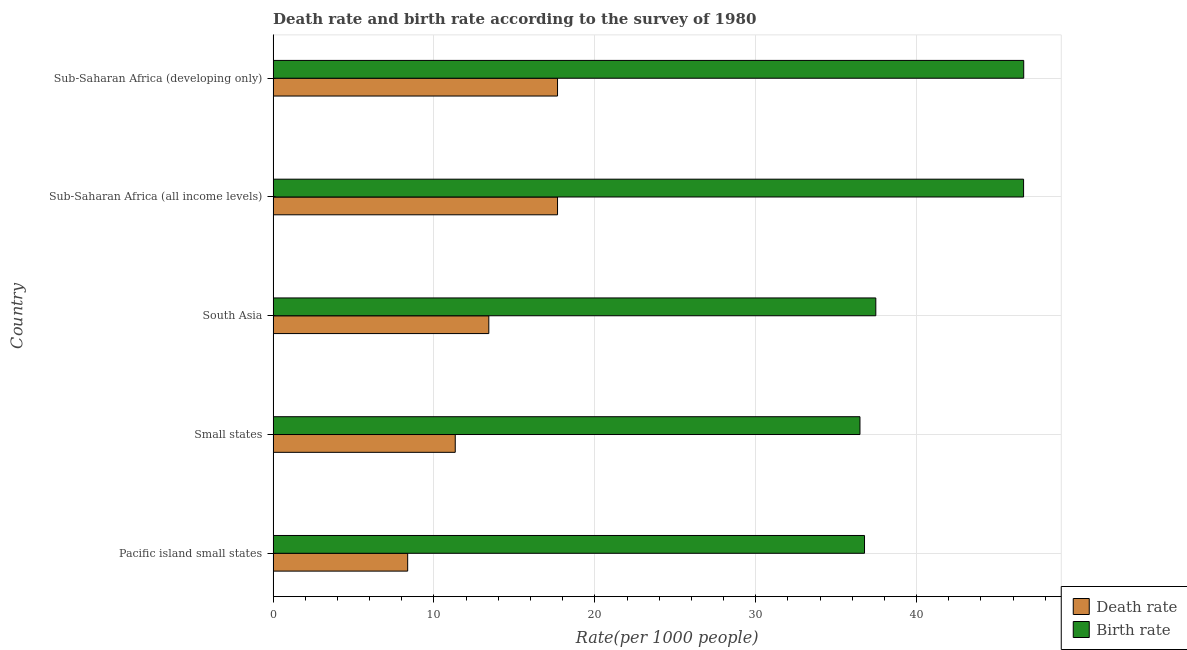How many different coloured bars are there?
Offer a very short reply. 2. Are the number of bars per tick equal to the number of legend labels?
Provide a succinct answer. Yes. Are the number of bars on each tick of the Y-axis equal?
Offer a very short reply. Yes. How many bars are there on the 4th tick from the top?
Keep it short and to the point. 2. How many bars are there on the 4th tick from the bottom?
Give a very brief answer. 2. What is the label of the 2nd group of bars from the top?
Ensure brevity in your answer.  Sub-Saharan Africa (all income levels). In how many cases, is the number of bars for a given country not equal to the number of legend labels?
Provide a succinct answer. 0. What is the birth rate in South Asia?
Give a very brief answer. 37.47. Across all countries, what is the maximum death rate?
Offer a very short reply. 17.68. Across all countries, what is the minimum birth rate?
Make the answer very short. 36.48. In which country was the birth rate maximum?
Offer a terse response. Sub-Saharan Africa (developing only). In which country was the birth rate minimum?
Your response must be concise. Small states. What is the total birth rate in the graph?
Provide a short and direct response. 204.03. What is the difference between the birth rate in Pacific island small states and that in Sub-Saharan Africa (developing only)?
Keep it short and to the point. -9.9. What is the difference between the death rate in South Asia and the birth rate in Sub-Saharan Africa (developing only)?
Give a very brief answer. -33.25. What is the average death rate per country?
Provide a short and direct response. 13.69. What is the difference between the death rate and birth rate in Pacific island small states?
Your answer should be very brief. -28.4. What is the ratio of the birth rate in Pacific island small states to that in Sub-Saharan Africa (all income levels)?
Provide a succinct answer. 0.79. Is the difference between the death rate in Pacific island small states and Sub-Saharan Africa (developing only) greater than the difference between the birth rate in Pacific island small states and Sub-Saharan Africa (developing only)?
Make the answer very short. Yes. What is the difference between the highest and the second highest birth rate?
Ensure brevity in your answer.  0.01. What is the difference between the highest and the lowest birth rate?
Your response must be concise. 10.18. What does the 1st bar from the top in Sub-Saharan Africa (developing only) represents?
Provide a short and direct response. Birth rate. What does the 1st bar from the bottom in Sub-Saharan Africa (developing only) represents?
Offer a very short reply. Death rate. Are all the bars in the graph horizontal?
Your answer should be compact. Yes. How many countries are there in the graph?
Your answer should be compact. 5. What is the difference between two consecutive major ticks on the X-axis?
Your answer should be very brief. 10. Are the values on the major ticks of X-axis written in scientific E-notation?
Your answer should be very brief. No. Does the graph contain any zero values?
Give a very brief answer. No. What is the title of the graph?
Your answer should be very brief. Death rate and birth rate according to the survey of 1980. Does "Taxes on profits and capital gains" appear as one of the legend labels in the graph?
Provide a succinct answer. No. What is the label or title of the X-axis?
Keep it short and to the point. Rate(per 1000 people). What is the label or title of the Y-axis?
Give a very brief answer. Country. What is the Rate(per 1000 people) in Death rate in Pacific island small states?
Keep it short and to the point. 8.36. What is the Rate(per 1000 people) in Birth rate in Pacific island small states?
Make the answer very short. 36.76. What is the Rate(per 1000 people) of Death rate in Small states?
Ensure brevity in your answer.  11.32. What is the Rate(per 1000 people) in Birth rate in Small states?
Your answer should be compact. 36.48. What is the Rate(per 1000 people) of Death rate in South Asia?
Your response must be concise. 13.41. What is the Rate(per 1000 people) in Birth rate in South Asia?
Ensure brevity in your answer.  37.47. What is the Rate(per 1000 people) of Death rate in Sub-Saharan Africa (all income levels)?
Ensure brevity in your answer.  17.68. What is the Rate(per 1000 people) in Birth rate in Sub-Saharan Africa (all income levels)?
Your response must be concise. 46.65. What is the Rate(per 1000 people) in Death rate in Sub-Saharan Africa (developing only)?
Your answer should be very brief. 17.68. What is the Rate(per 1000 people) in Birth rate in Sub-Saharan Africa (developing only)?
Offer a very short reply. 46.66. Across all countries, what is the maximum Rate(per 1000 people) in Death rate?
Make the answer very short. 17.68. Across all countries, what is the maximum Rate(per 1000 people) of Birth rate?
Offer a terse response. 46.66. Across all countries, what is the minimum Rate(per 1000 people) in Death rate?
Offer a terse response. 8.36. Across all countries, what is the minimum Rate(per 1000 people) in Birth rate?
Give a very brief answer. 36.48. What is the total Rate(per 1000 people) of Death rate in the graph?
Provide a succinct answer. 68.46. What is the total Rate(per 1000 people) of Birth rate in the graph?
Offer a terse response. 204.03. What is the difference between the Rate(per 1000 people) in Death rate in Pacific island small states and that in Small states?
Your answer should be very brief. -2.96. What is the difference between the Rate(per 1000 people) of Birth rate in Pacific island small states and that in Small states?
Provide a succinct answer. 0.28. What is the difference between the Rate(per 1000 people) in Death rate in Pacific island small states and that in South Asia?
Give a very brief answer. -5.04. What is the difference between the Rate(per 1000 people) in Birth rate in Pacific island small states and that in South Asia?
Provide a succinct answer. -0.7. What is the difference between the Rate(per 1000 people) of Death rate in Pacific island small states and that in Sub-Saharan Africa (all income levels)?
Your response must be concise. -9.32. What is the difference between the Rate(per 1000 people) of Birth rate in Pacific island small states and that in Sub-Saharan Africa (all income levels)?
Provide a succinct answer. -9.89. What is the difference between the Rate(per 1000 people) in Death rate in Pacific island small states and that in Sub-Saharan Africa (developing only)?
Your answer should be compact. -9.32. What is the difference between the Rate(per 1000 people) in Birth rate in Pacific island small states and that in Sub-Saharan Africa (developing only)?
Ensure brevity in your answer.  -9.9. What is the difference between the Rate(per 1000 people) of Death rate in Small states and that in South Asia?
Ensure brevity in your answer.  -2.09. What is the difference between the Rate(per 1000 people) of Birth rate in Small states and that in South Asia?
Your answer should be very brief. -0.98. What is the difference between the Rate(per 1000 people) in Death rate in Small states and that in Sub-Saharan Africa (all income levels)?
Your response must be concise. -6.36. What is the difference between the Rate(per 1000 people) of Birth rate in Small states and that in Sub-Saharan Africa (all income levels)?
Offer a terse response. -10.17. What is the difference between the Rate(per 1000 people) in Death rate in Small states and that in Sub-Saharan Africa (developing only)?
Give a very brief answer. -6.36. What is the difference between the Rate(per 1000 people) of Birth rate in Small states and that in Sub-Saharan Africa (developing only)?
Offer a very short reply. -10.18. What is the difference between the Rate(per 1000 people) in Death rate in South Asia and that in Sub-Saharan Africa (all income levels)?
Your response must be concise. -4.27. What is the difference between the Rate(per 1000 people) in Birth rate in South Asia and that in Sub-Saharan Africa (all income levels)?
Your answer should be very brief. -9.19. What is the difference between the Rate(per 1000 people) in Death rate in South Asia and that in Sub-Saharan Africa (developing only)?
Ensure brevity in your answer.  -4.27. What is the difference between the Rate(per 1000 people) of Birth rate in South Asia and that in Sub-Saharan Africa (developing only)?
Your answer should be compact. -9.2. What is the difference between the Rate(per 1000 people) of Death rate in Sub-Saharan Africa (all income levels) and that in Sub-Saharan Africa (developing only)?
Provide a succinct answer. 0. What is the difference between the Rate(per 1000 people) in Birth rate in Sub-Saharan Africa (all income levels) and that in Sub-Saharan Africa (developing only)?
Offer a terse response. -0.01. What is the difference between the Rate(per 1000 people) in Death rate in Pacific island small states and the Rate(per 1000 people) in Birth rate in Small states?
Offer a very short reply. -28.12. What is the difference between the Rate(per 1000 people) of Death rate in Pacific island small states and the Rate(per 1000 people) of Birth rate in South Asia?
Your answer should be compact. -29.1. What is the difference between the Rate(per 1000 people) in Death rate in Pacific island small states and the Rate(per 1000 people) in Birth rate in Sub-Saharan Africa (all income levels)?
Give a very brief answer. -38.29. What is the difference between the Rate(per 1000 people) of Death rate in Pacific island small states and the Rate(per 1000 people) of Birth rate in Sub-Saharan Africa (developing only)?
Offer a very short reply. -38.3. What is the difference between the Rate(per 1000 people) in Death rate in Small states and the Rate(per 1000 people) in Birth rate in South Asia?
Make the answer very short. -26.14. What is the difference between the Rate(per 1000 people) of Death rate in Small states and the Rate(per 1000 people) of Birth rate in Sub-Saharan Africa (all income levels)?
Offer a very short reply. -35.33. What is the difference between the Rate(per 1000 people) of Death rate in Small states and the Rate(per 1000 people) of Birth rate in Sub-Saharan Africa (developing only)?
Give a very brief answer. -35.34. What is the difference between the Rate(per 1000 people) in Death rate in South Asia and the Rate(per 1000 people) in Birth rate in Sub-Saharan Africa (all income levels)?
Offer a very short reply. -33.24. What is the difference between the Rate(per 1000 people) of Death rate in South Asia and the Rate(per 1000 people) of Birth rate in Sub-Saharan Africa (developing only)?
Offer a terse response. -33.25. What is the difference between the Rate(per 1000 people) of Death rate in Sub-Saharan Africa (all income levels) and the Rate(per 1000 people) of Birth rate in Sub-Saharan Africa (developing only)?
Ensure brevity in your answer.  -28.98. What is the average Rate(per 1000 people) in Death rate per country?
Your response must be concise. 13.69. What is the average Rate(per 1000 people) in Birth rate per country?
Offer a terse response. 40.81. What is the difference between the Rate(per 1000 people) of Death rate and Rate(per 1000 people) of Birth rate in Pacific island small states?
Make the answer very short. -28.4. What is the difference between the Rate(per 1000 people) of Death rate and Rate(per 1000 people) of Birth rate in Small states?
Provide a short and direct response. -25.16. What is the difference between the Rate(per 1000 people) of Death rate and Rate(per 1000 people) of Birth rate in South Asia?
Keep it short and to the point. -24.06. What is the difference between the Rate(per 1000 people) in Death rate and Rate(per 1000 people) in Birth rate in Sub-Saharan Africa (all income levels)?
Keep it short and to the point. -28.97. What is the difference between the Rate(per 1000 people) of Death rate and Rate(per 1000 people) of Birth rate in Sub-Saharan Africa (developing only)?
Make the answer very short. -28.98. What is the ratio of the Rate(per 1000 people) of Death rate in Pacific island small states to that in Small states?
Your answer should be compact. 0.74. What is the ratio of the Rate(per 1000 people) in Birth rate in Pacific island small states to that in Small states?
Provide a succinct answer. 1.01. What is the ratio of the Rate(per 1000 people) of Death rate in Pacific island small states to that in South Asia?
Ensure brevity in your answer.  0.62. What is the ratio of the Rate(per 1000 people) in Birth rate in Pacific island small states to that in South Asia?
Keep it short and to the point. 0.98. What is the ratio of the Rate(per 1000 people) in Death rate in Pacific island small states to that in Sub-Saharan Africa (all income levels)?
Make the answer very short. 0.47. What is the ratio of the Rate(per 1000 people) in Birth rate in Pacific island small states to that in Sub-Saharan Africa (all income levels)?
Your answer should be very brief. 0.79. What is the ratio of the Rate(per 1000 people) of Death rate in Pacific island small states to that in Sub-Saharan Africa (developing only)?
Provide a succinct answer. 0.47. What is the ratio of the Rate(per 1000 people) in Birth rate in Pacific island small states to that in Sub-Saharan Africa (developing only)?
Give a very brief answer. 0.79. What is the ratio of the Rate(per 1000 people) of Death rate in Small states to that in South Asia?
Make the answer very short. 0.84. What is the ratio of the Rate(per 1000 people) of Birth rate in Small states to that in South Asia?
Ensure brevity in your answer.  0.97. What is the ratio of the Rate(per 1000 people) in Death rate in Small states to that in Sub-Saharan Africa (all income levels)?
Ensure brevity in your answer.  0.64. What is the ratio of the Rate(per 1000 people) in Birth rate in Small states to that in Sub-Saharan Africa (all income levels)?
Your answer should be compact. 0.78. What is the ratio of the Rate(per 1000 people) of Death rate in Small states to that in Sub-Saharan Africa (developing only)?
Offer a terse response. 0.64. What is the ratio of the Rate(per 1000 people) in Birth rate in Small states to that in Sub-Saharan Africa (developing only)?
Make the answer very short. 0.78. What is the ratio of the Rate(per 1000 people) in Death rate in South Asia to that in Sub-Saharan Africa (all income levels)?
Your answer should be very brief. 0.76. What is the ratio of the Rate(per 1000 people) in Birth rate in South Asia to that in Sub-Saharan Africa (all income levels)?
Your answer should be very brief. 0.8. What is the ratio of the Rate(per 1000 people) in Death rate in South Asia to that in Sub-Saharan Africa (developing only)?
Provide a succinct answer. 0.76. What is the ratio of the Rate(per 1000 people) of Birth rate in South Asia to that in Sub-Saharan Africa (developing only)?
Provide a short and direct response. 0.8. What is the ratio of the Rate(per 1000 people) in Birth rate in Sub-Saharan Africa (all income levels) to that in Sub-Saharan Africa (developing only)?
Give a very brief answer. 1. What is the difference between the highest and the second highest Rate(per 1000 people) of Death rate?
Provide a succinct answer. 0. What is the difference between the highest and the second highest Rate(per 1000 people) in Birth rate?
Ensure brevity in your answer.  0.01. What is the difference between the highest and the lowest Rate(per 1000 people) of Death rate?
Give a very brief answer. 9.32. What is the difference between the highest and the lowest Rate(per 1000 people) of Birth rate?
Offer a very short reply. 10.18. 